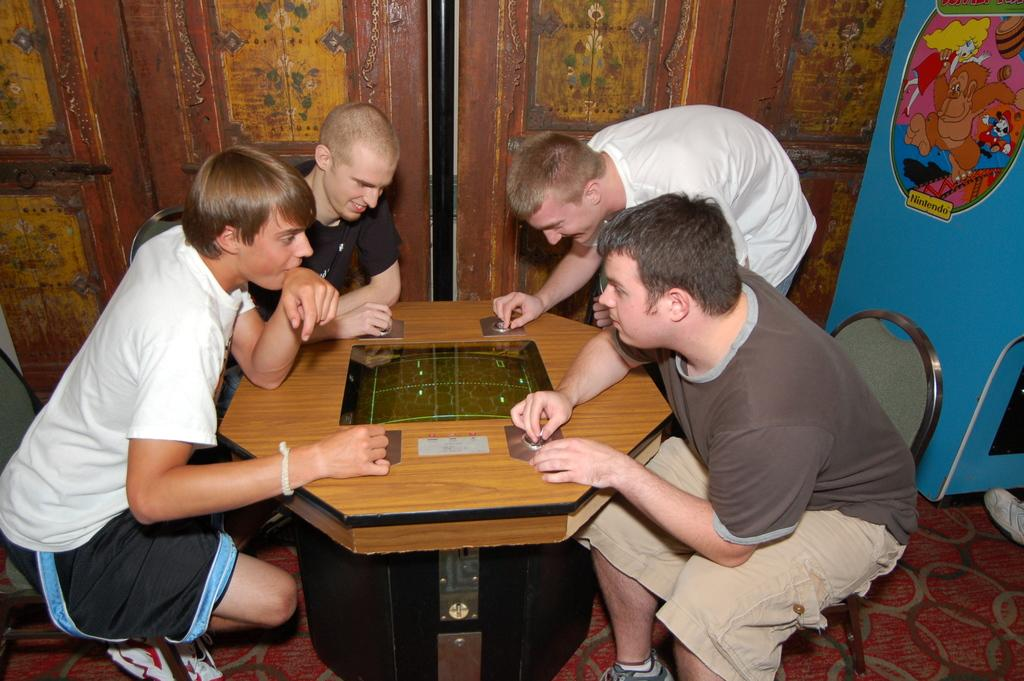How many people are in the image? There are four men in the image. What are the men doing in the image? The men are playing on a table. What can be seen in the background of the image? There is a door in the background of the image. What is on the table besides the men? There is a glass on the table. What type of end is visible in the image? There is no end visible in the image; it is a scene of men playing on a table. Can you tell me how many apples are on the table in the image? There are no apples present in the image; only a glass is visible on the table. 